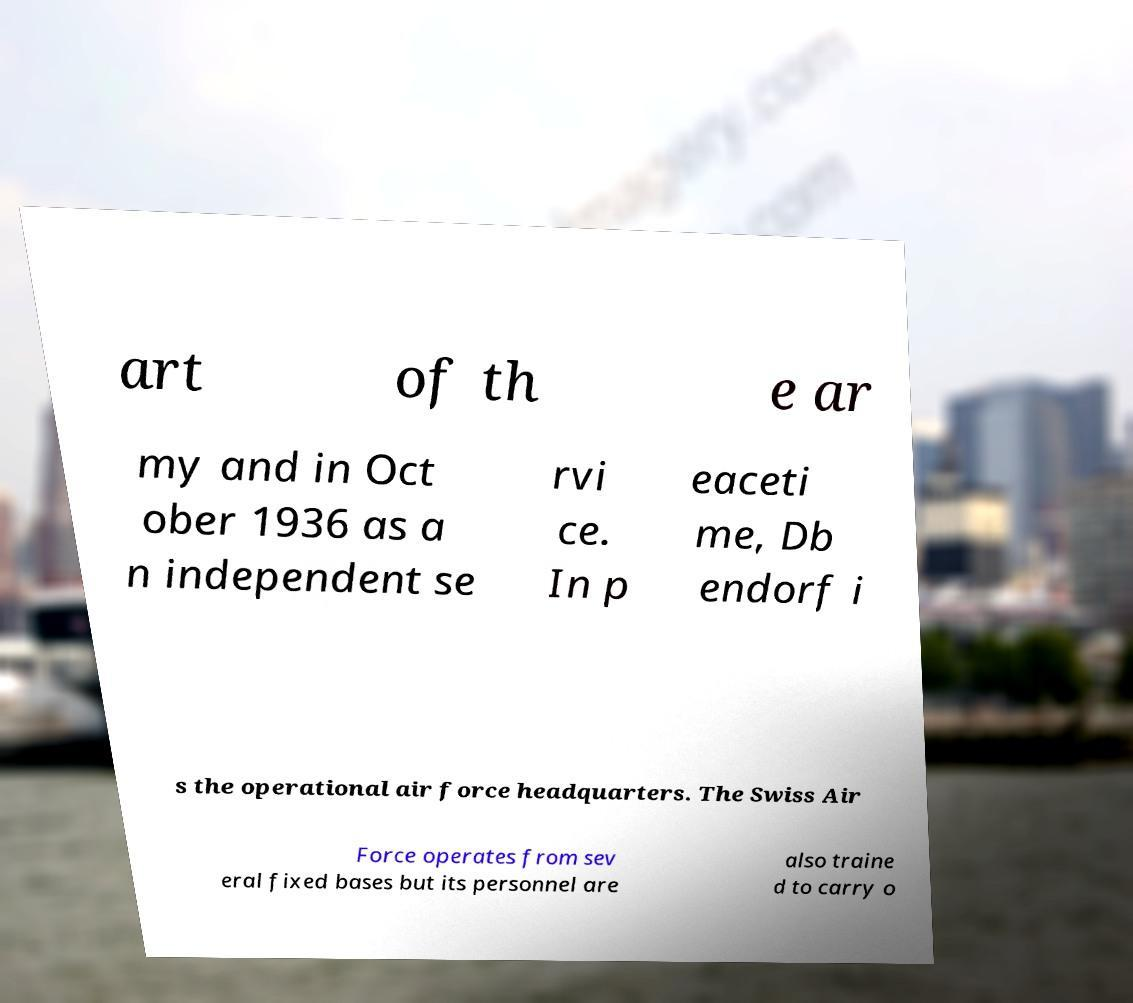For documentation purposes, I need the text within this image transcribed. Could you provide that? art of th e ar my and in Oct ober 1936 as a n independent se rvi ce. In p eaceti me, Db endorf i s the operational air force headquarters. The Swiss Air Force operates from sev eral fixed bases but its personnel are also traine d to carry o 